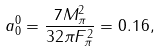<formula> <loc_0><loc_0><loc_500><loc_500>a _ { 0 } ^ { 0 } = \frac { 7 M _ { \pi } ^ { 2 } } { 3 2 \pi F _ { \pi } ^ { 2 } } = 0 . 1 6 ,</formula> 